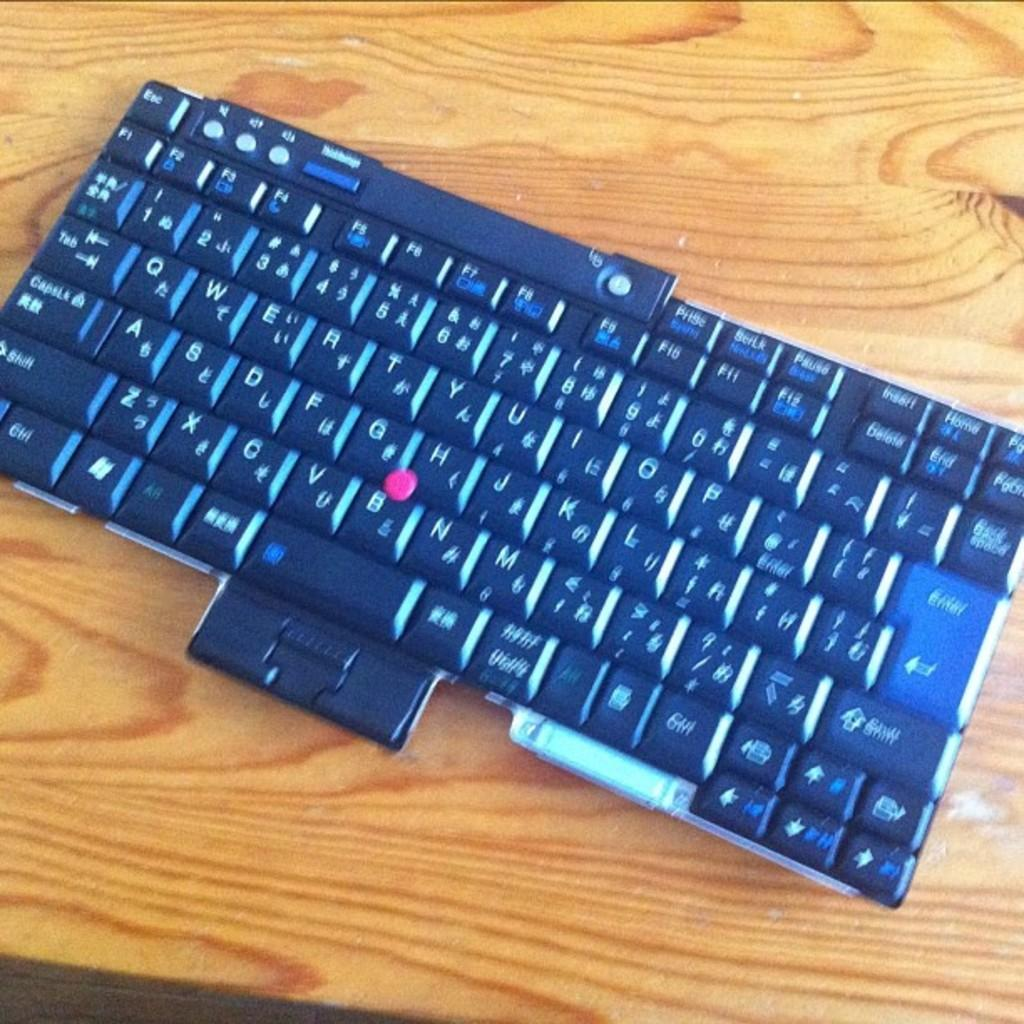<image>
Create a compact narrative representing the image presented. a keyboard with the letters a-z with a red dot between the letters g, h and b 